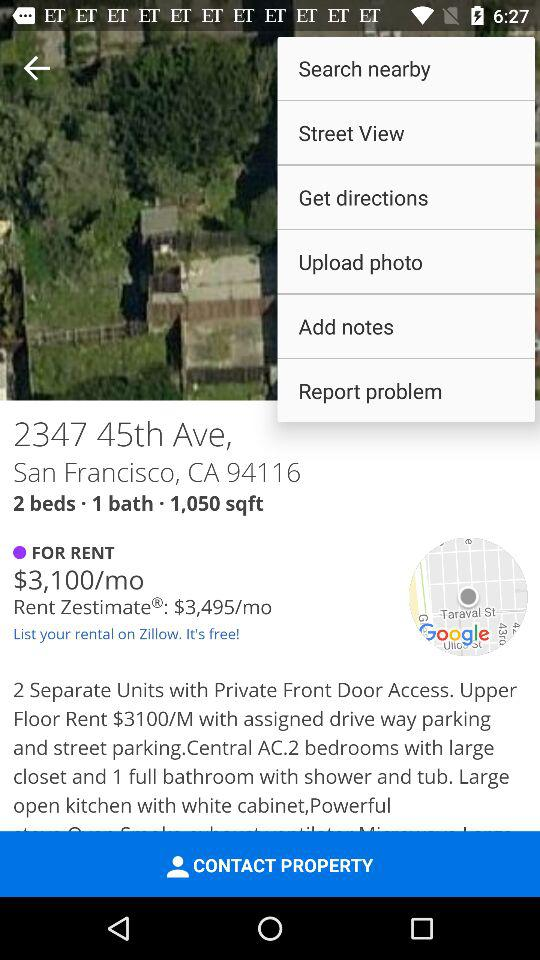What is the count of the bathrooms? The count of the bathrooms is 1. 